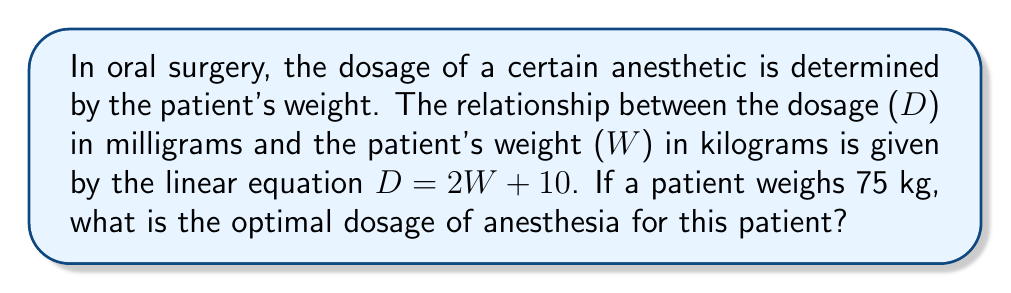Can you answer this question? To solve this problem, we'll follow these steps:

1) We are given the linear equation: $D = 2W + 10$
   Where D is the dosage in milligrams and W is the patient's weight in kilograms.

2) We know the patient's weight: W = 75 kg

3) To find the optimal dosage, we simply need to substitute the weight into the equation:

   $D = 2W + 10$
   $D = 2(75) + 10$

4) Let's calculate:
   $D = 150 + 10$
   $D = 160$

Therefore, the optimal dosage of anesthesia for a patient weighing 75 kg is 160 mg.
Answer: 160 mg 